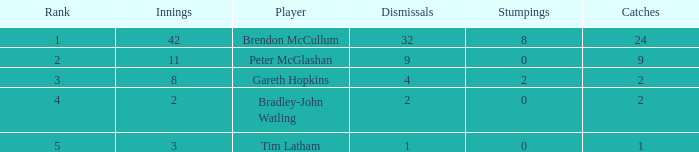List the ranks of all dismissals with a value of 4 3.0. 